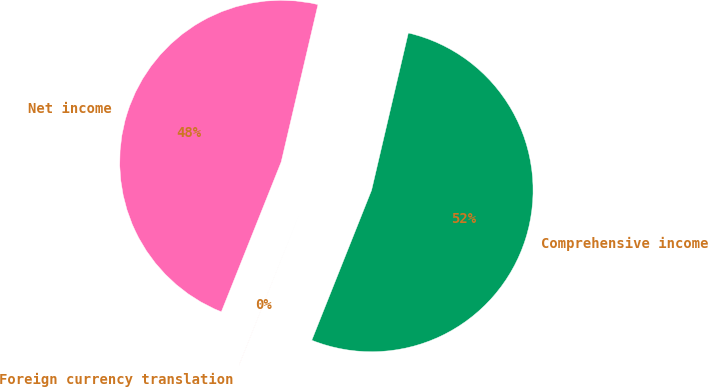<chart> <loc_0><loc_0><loc_500><loc_500><pie_chart><fcel>Net income<fcel>Foreign currency translation<fcel>Comprehensive income<nl><fcel>47.61%<fcel>0.01%<fcel>52.38%<nl></chart> 